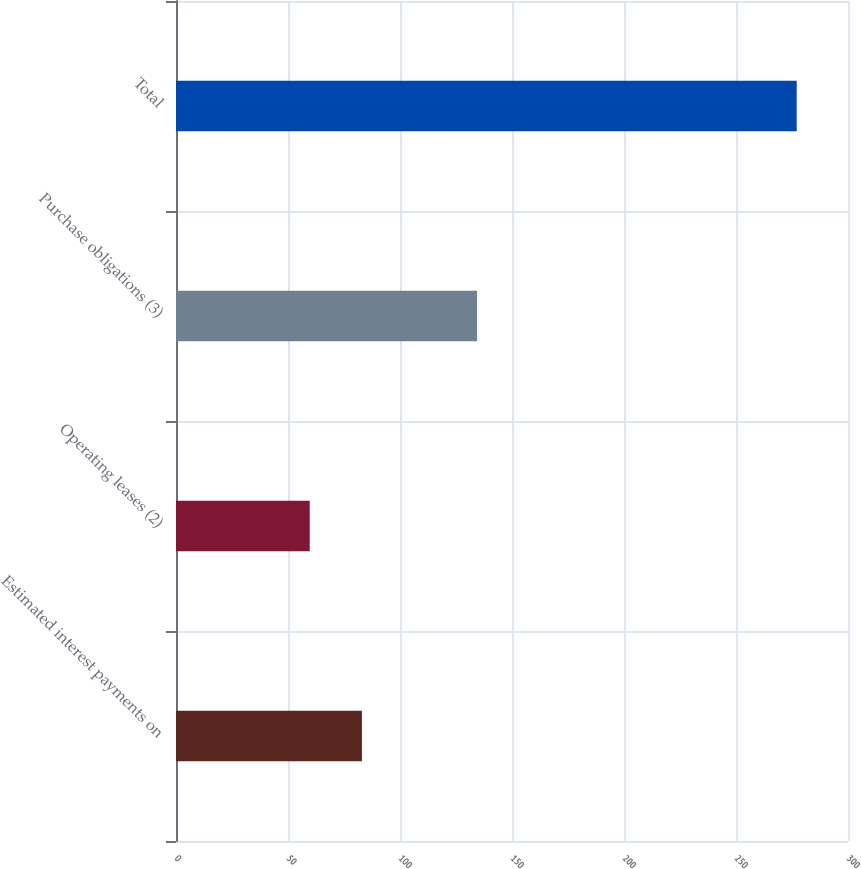Convert chart. <chart><loc_0><loc_0><loc_500><loc_500><bar_chart><fcel>Estimated interest payments on<fcel>Operating leases (2)<fcel>Purchase obligations (3)<fcel>Total<nl><fcel>83<fcel>59.7<fcel>134.4<fcel>277.1<nl></chart> 